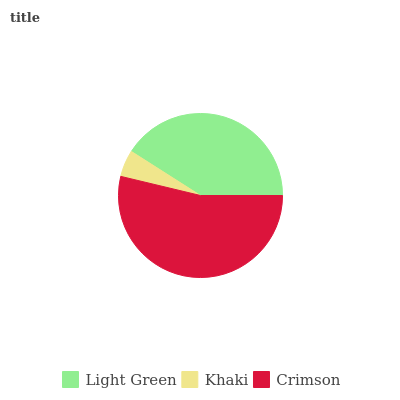Is Khaki the minimum?
Answer yes or no. Yes. Is Crimson the maximum?
Answer yes or no. Yes. Is Crimson the minimum?
Answer yes or no. No. Is Khaki the maximum?
Answer yes or no. No. Is Crimson greater than Khaki?
Answer yes or no. Yes. Is Khaki less than Crimson?
Answer yes or no. Yes. Is Khaki greater than Crimson?
Answer yes or no. No. Is Crimson less than Khaki?
Answer yes or no. No. Is Light Green the high median?
Answer yes or no. Yes. Is Light Green the low median?
Answer yes or no. Yes. Is Crimson the high median?
Answer yes or no. No. Is Crimson the low median?
Answer yes or no. No. 